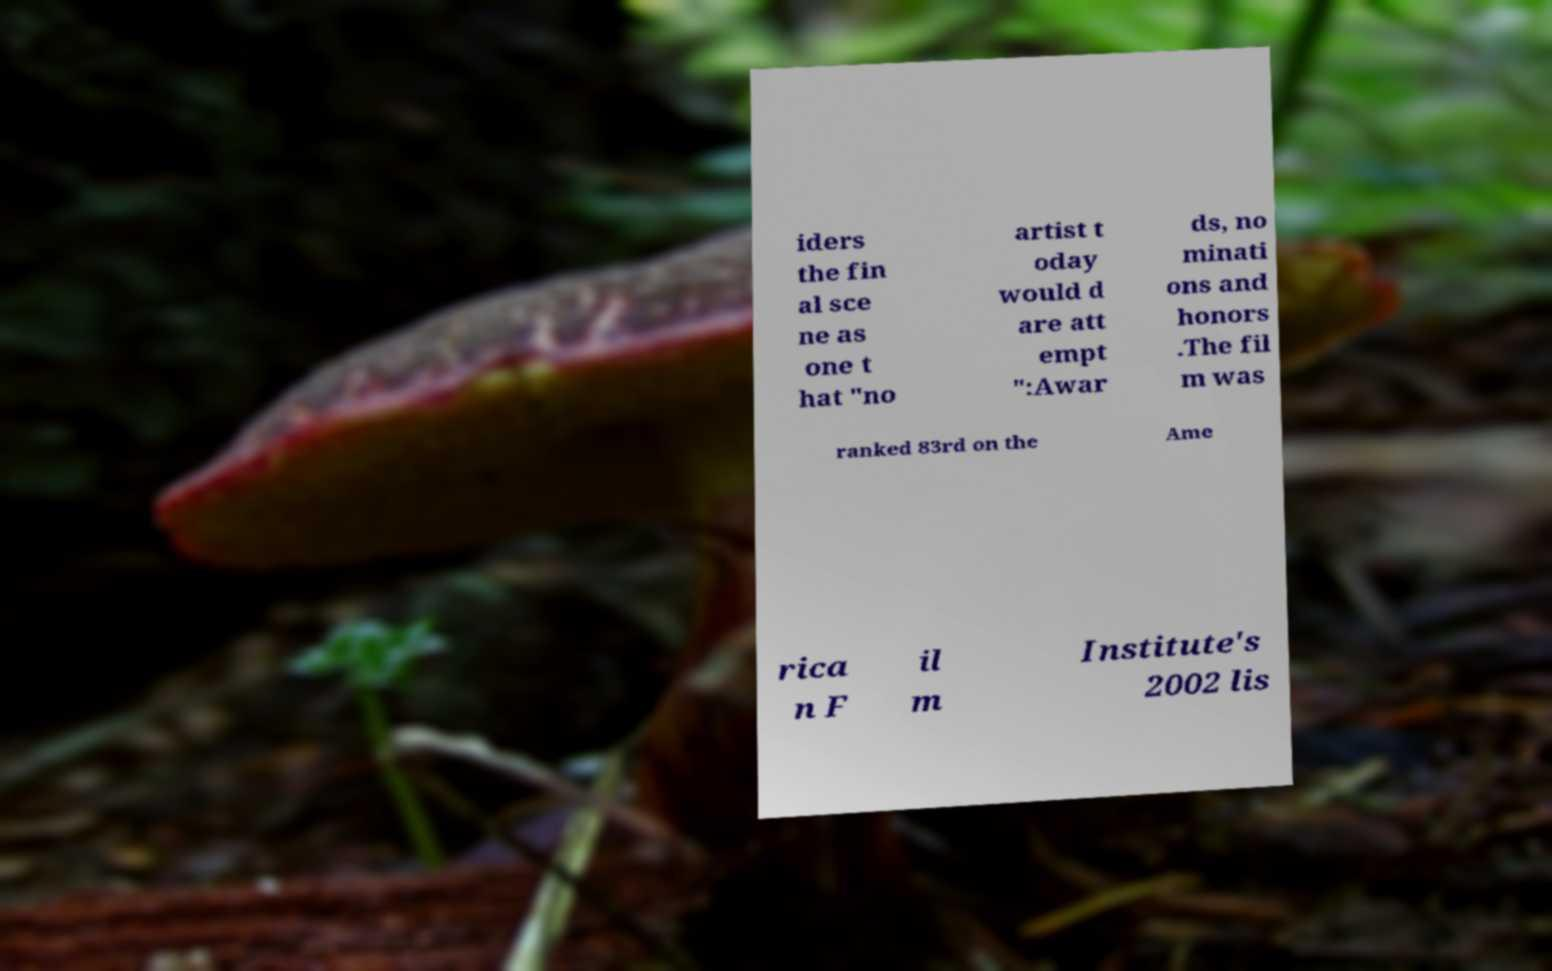Could you assist in decoding the text presented in this image and type it out clearly? iders the fin al sce ne as one t hat "no artist t oday would d are att empt ":Awar ds, no minati ons and honors .The fil m was ranked 83rd on the Ame rica n F il m Institute's 2002 lis 